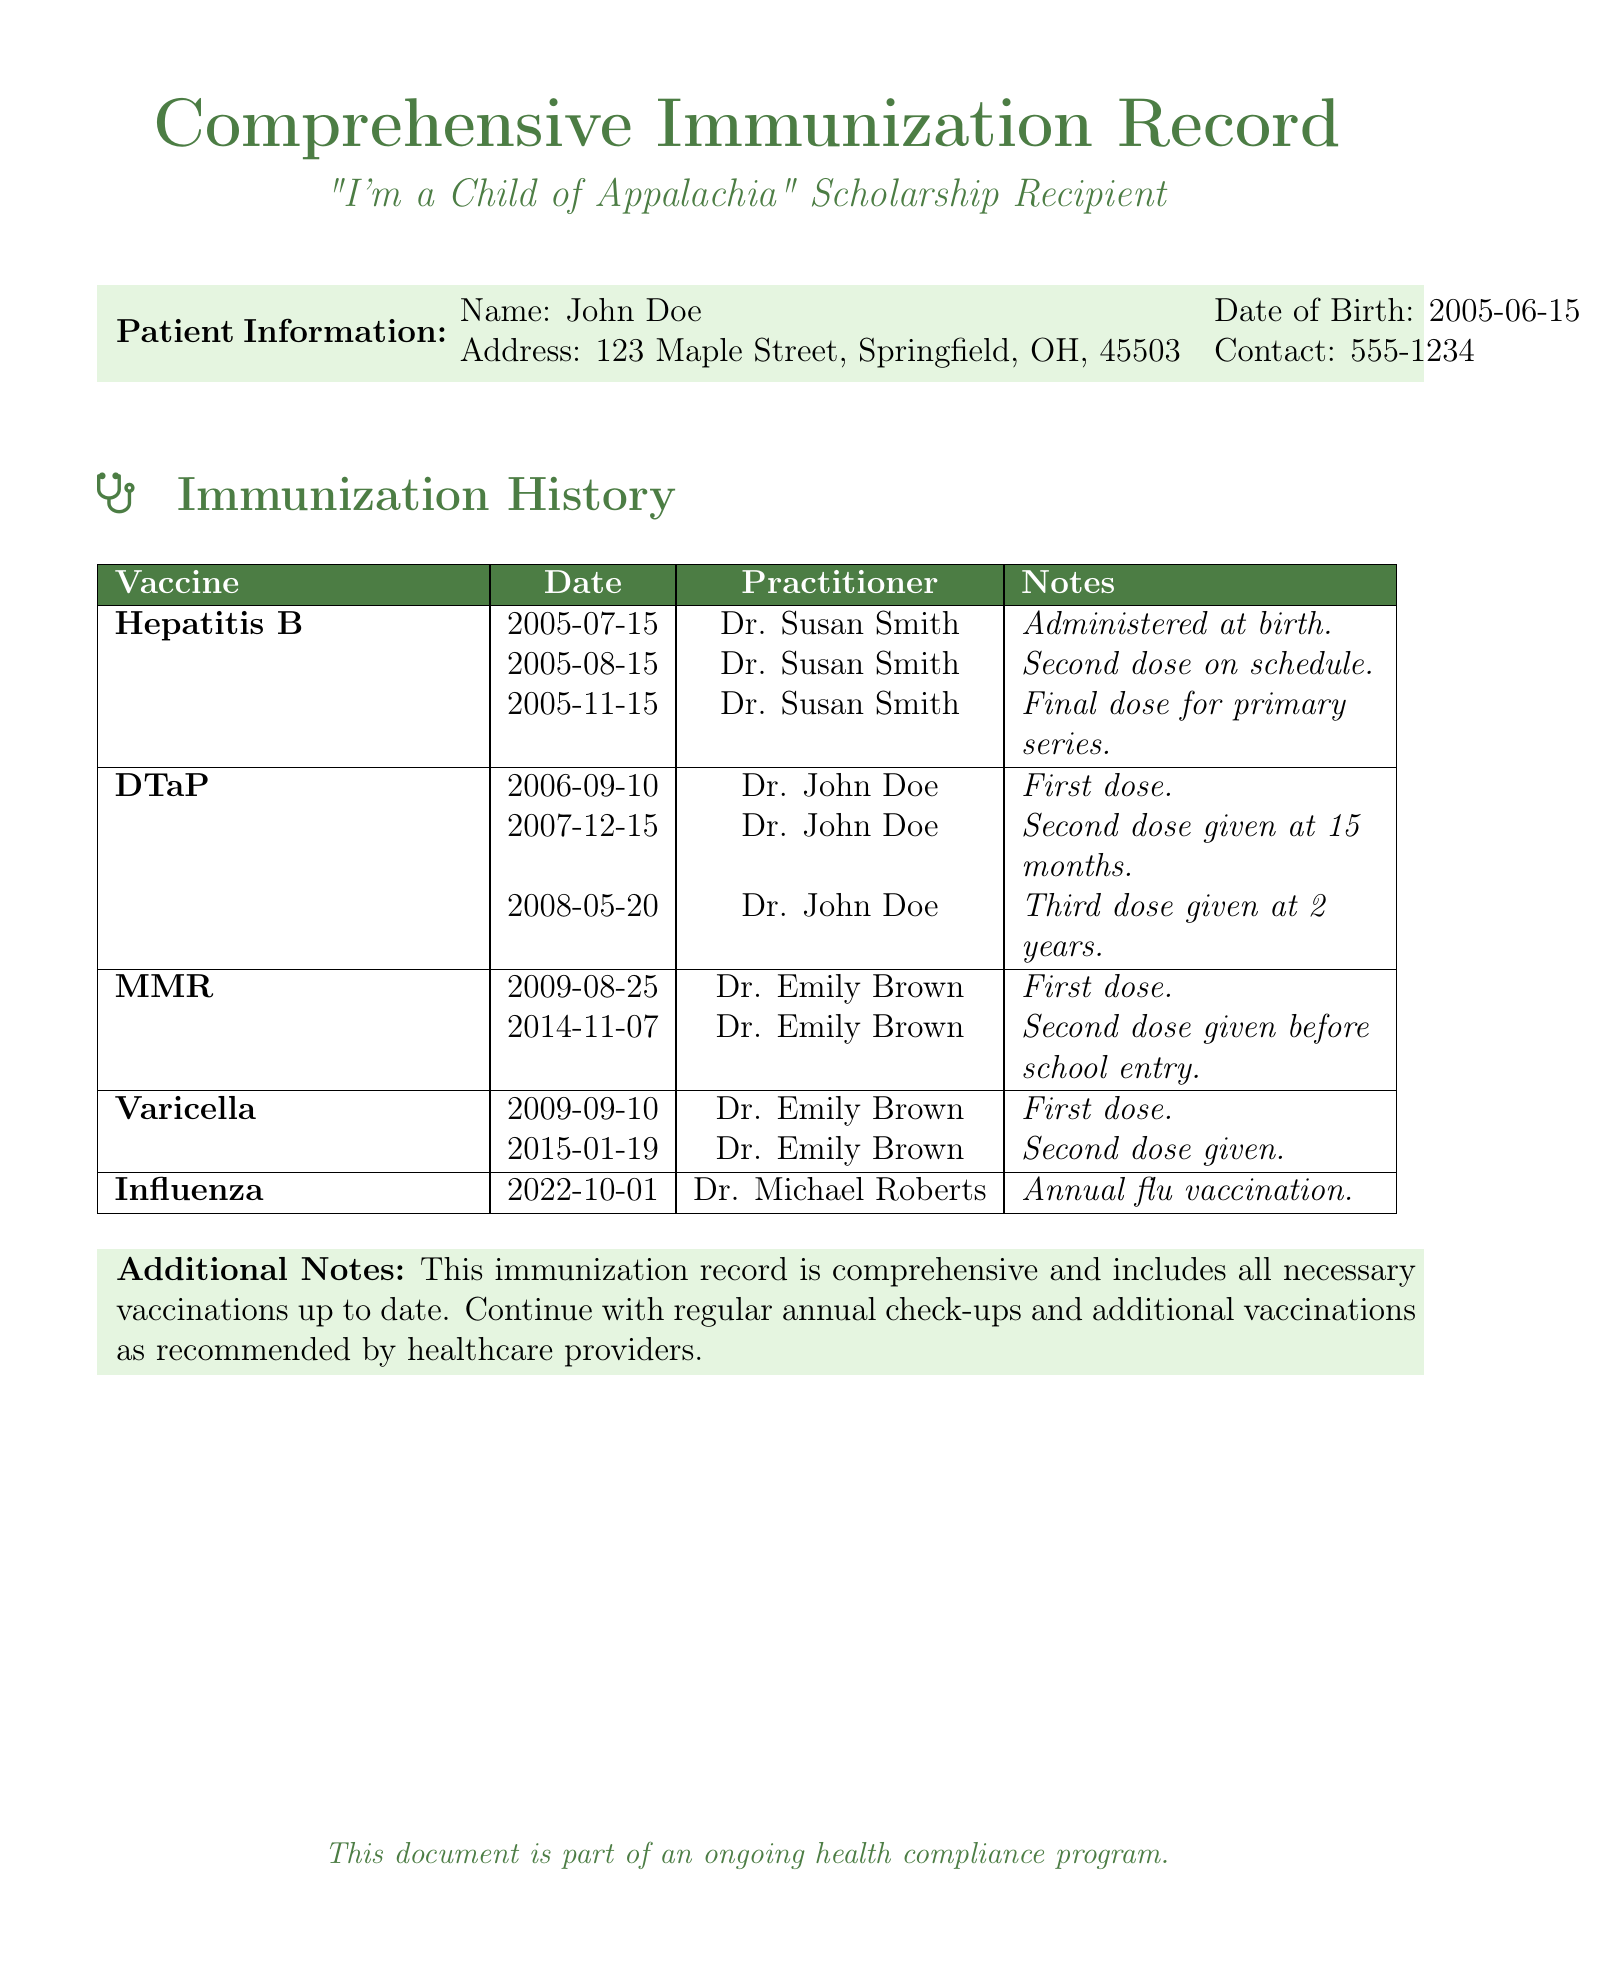What is the patient's name? The patient's name is listed in the patient information section of the document.
Answer: John Doe What is the date of birth of the patient? The patient's date of birth is provided in the patient information section.
Answer: 2005-06-15 How many doses of Hepatitis B were administered? The document lists the dates for each of the three doses administered.
Answer: Three Who administered the first dose of DTaP? The name of the medical practitioner who administered the first dose of DTaP is noted in the immunization history.
Answer: Dr. John Doe What was the date of the second dose of MMR? The document specifies the date when the second dose of MMR was administered.
Answer: 2014-11-07 Which vaccine was administered on 2022-10-01? The document provides the vaccine name corresponding to this date in the immunization history.
Answer: Influenza Why is the immunization record significant? The additional notes mention the importance of the record in the context of ongoing health compliance.
Answer: Ongoing health compliance How many vaccinations are listed in total? The total number of unique vaccinations is counted from the immunization history.
Answer: Five What color is used for the title of the document? The document specifies the color used for the title prominently at the beginning.
Answer: Appalachian 